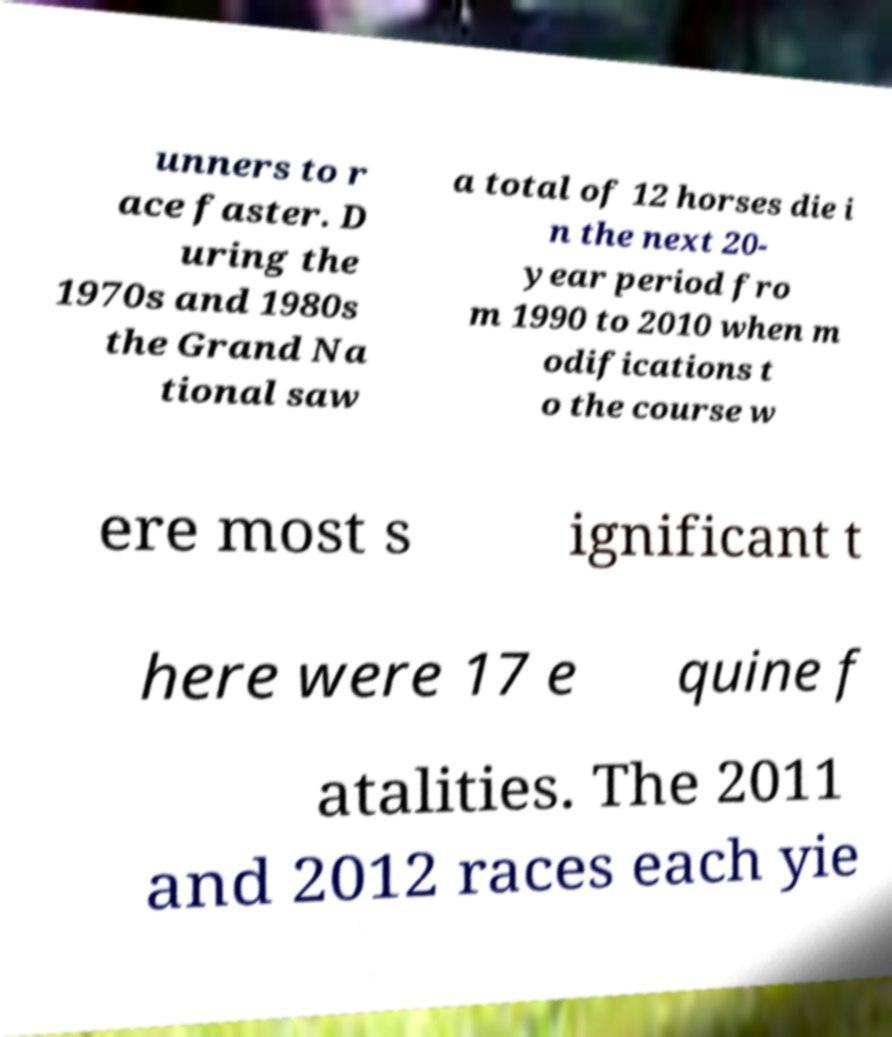I need the written content from this picture converted into text. Can you do that? unners to r ace faster. D uring the 1970s and 1980s the Grand Na tional saw a total of 12 horses die i n the next 20- year period fro m 1990 to 2010 when m odifications t o the course w ere most s ignificant t here were 17 e quine f atalities. The 2011 and 2012 races each yie 